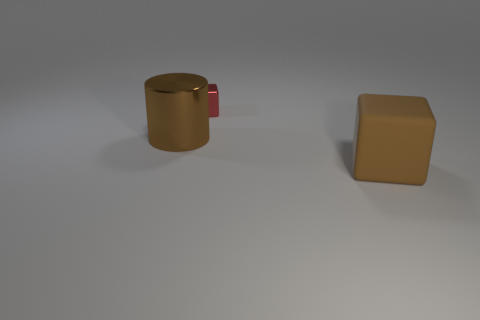Are there any large brown cubes behind the big brown cylinder?
Your response must be concise. No. How many big cubes are the same material as the large cylinder?
Provide a short and direct response. 0. How many things are either purple matte objects or tiny things?
Offer a terse response. 1. Are any tiny cyan rubber things visible?
Provide a succinct answer. No. There is a brown thing to the left of the cube that is in front of the brown thing that is left of the large brown matte object; what is it made of?
Ensure brevity in your answer.  Metal. Is the number of brown matte cubes in front of the small red block less than the number of large cylinders?
Keep it short and to the point. No. There is a cylinder that is the same size as the brown matte object; what material is it?
Your answer should be compact. Metal. There is a object that is behind the matte thing and right of the cylinder; what is its size?
Give a very brief answer. Small. What is the size of the other object that is the same shape as the matte object?
Your answer should be compact. Small. What number of things are large blue cylinders or large objects that are in front of the large cylinder?
Give a very brief answer. 1. 